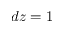<formula> <loc_0><loc_0><loc_500><loc_500>d z = 1</formula> 